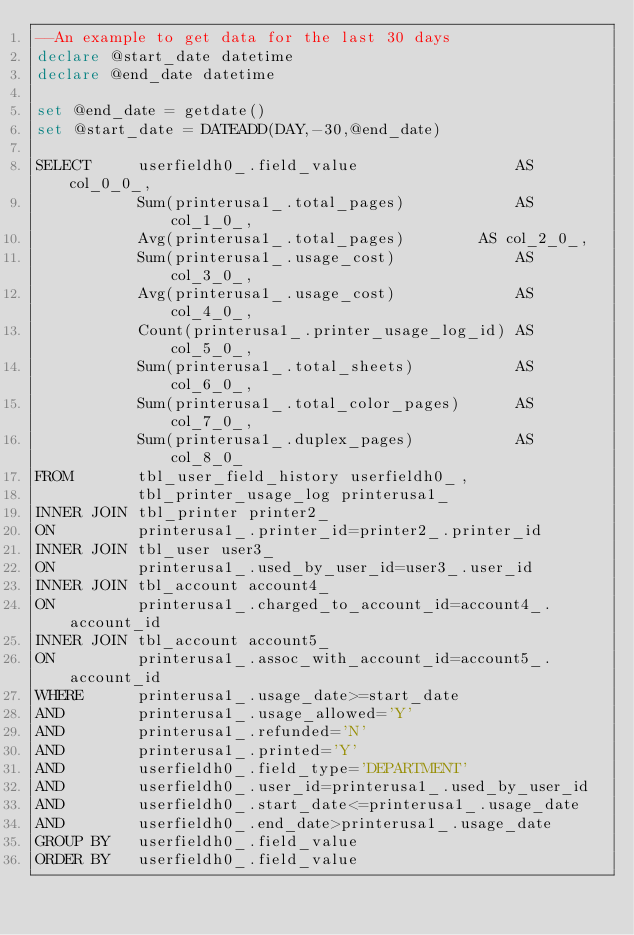<code> <loc_0><loc_0><loc_500><loc_500><_SQL_>--An example to get data for the last 30 days
declare @start_date datetime
declare @end_date datetime

set @end_date = getdate()
set @start_date = DATEADD(DAY,-30,@end_date)

SELECT     userfieldh0_.field_value                 AS col_0_0_, 
           Sum(printerusa1_.total_pages)            AS col_1_0_, 
           Avg(printerusa1_.total_pages)    		AS col_2_0_, 
           Sum(printerusa1_.usage_cost)             AS col_3_0_, 
           Avg(printerusa1_.usage_cost)             AS col_4_0_, 
           Count(printerusa1_.printer_usage_log_id) AS col_5_0_, 
           Sum(printerusa1_.total_sheets)           AS col_6_0_, 
           Sum(printerusa1_.total_color_pages)      AS col_7_0_, 
           Sum(printerusa1_.duplex_pages)           AS col_8_0_ 
FROM       tbl_user_field_history userfieldh0_, 
           tbl_printer_usage_log printerusa1_ 
INNER JOIN tbl_printer printer2_ 
ON         printerusa1_.printer_id=printer2_.printer_id 
INNER JOIN tbl_user user3_ 
ON         printerusa1_.used_by_user_id=user3_.user_id 
INNER JOIN tbl_account account4_ 
ON         printerusa1_.charged_to_account_id=account4_.account_id 
INNER JOIN tbl_account account5_ 
ON         printerusa1_.assoc_with_account_id=account5_.account_id 
WHERE      printerusa1_.usage_date>=start_date 
AND        printerusa1_.usage_allowed='Y'
AND        printerusa1_.refunded='N'
AND        printerusa1_.printed='Y'
AND        userfieldh0_.field_type='DEPARTMENT' 
AND        userfieldh0_.user_id=printerusa1_.used_by_user_id 
AND        userfieldh0_.start_date<=printerusa1_.usage_date 
AND        userfieldh0_.end_date>printerusa1_.usage_date 
GROUP BY   userfieldh0_.field_value 
ORDER BY   userfieldh0_.field_value </code> 